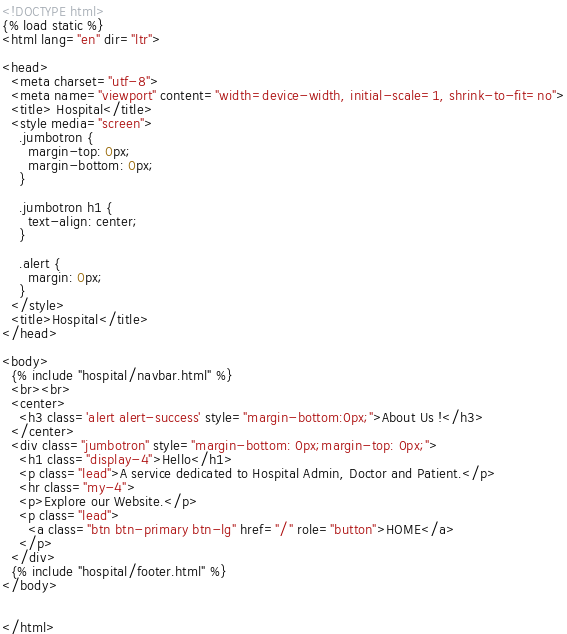<code> <loc_0><loc_0><loc_500><loc_500><_HTML_><!DOCTYPE html>
{% load static %}
<html lang="en" dir="ltr">

<head>
  <meta charset="utf-8">
  <meta name="viewport" content="width=device-width, initial-scale=1, shrink-to-fit=no">
  <title> Hospital</title>
  <style media="screen">
    .jumbotron {
      margin-top: 0px;
      margin-bottom: 0px;
    }

    .jumbotron h1 {
      text-align: center;
    }

    .alert {
      margin: 0px;
    }
  </style>
  <title>Hospital</title>
</head>

<body>
  {% include "hospital/navbar.html" %}
  <br><br>
  <center>
    <h3 class='alert alert-success' style="margin-bottom:0px;">About Us !</h3>
  </center>
  <div class="jumbotron" style="margin-bottom: 0px;margin-top: 0px;">
    <h1 class="display-4">Hello</h1>
    <p class="lead">A service dedicated to Hospital Admin, Doctor and Patient.</p>
    <hr class="my-4">
    <p>Explore our Website.</p>
    <p class="lead">
      <a class="btn btn-primary btn-lg" href="/" role="button">HOME</a>
    </p>
  </div>
  {% include "hospital/footer.html" %}
</body>


</html>
</code> 